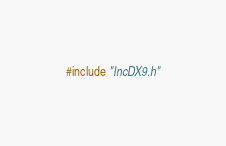<code> <loc_0><loc_0><loc_500><loc_500><_C++_>#include "IncDX9.h"
</code> 